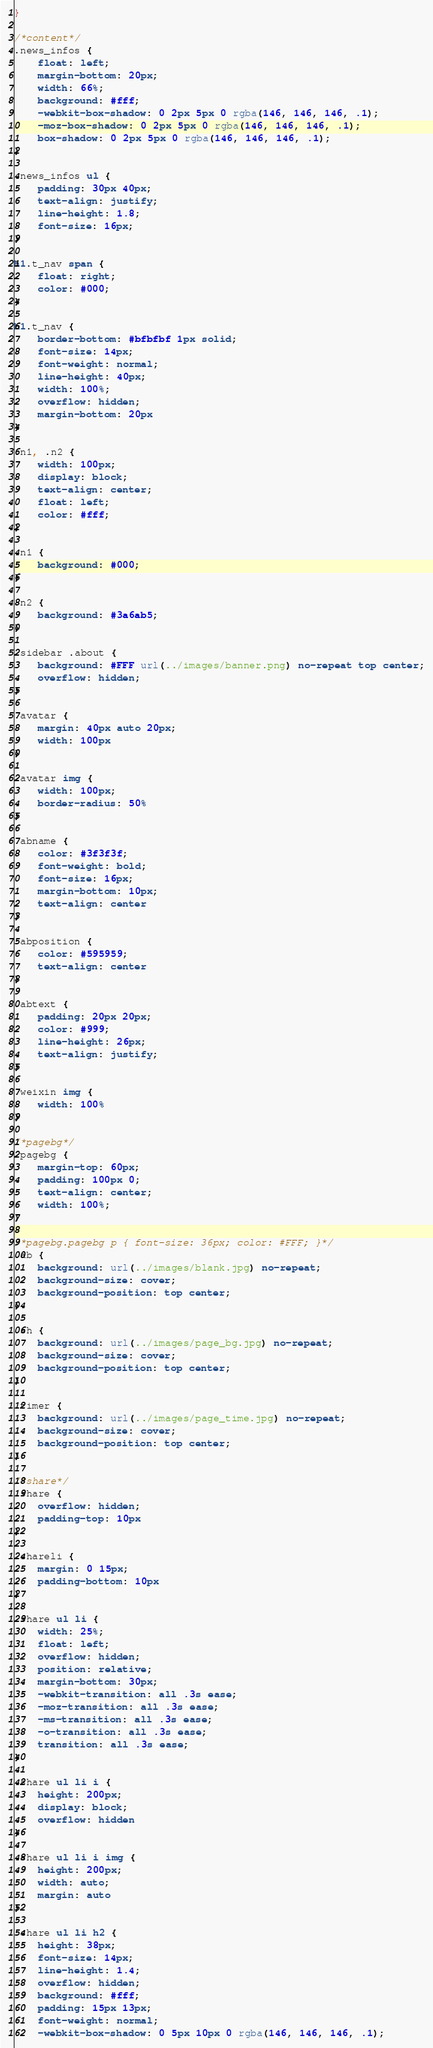<code> <loc_0><loc_0><loc_500><loc_500><_CSS_>}

/*content*/
.news_infos {
    float: left;
    margin-bottom: 20px;
    width: 66%;
    background: #fff;
    -webkit-box-shadow: 0 2px 5px 0 rgba(146, 146, 146, .1);
    -moz-box-shadow: 0 2px 5px 0 rgba(146, 146, 146, .1);
    box-shadow: 0 2px 5px 0 rgba(146, 146, 146, .1);
}

.news_infos ul {
    padding: 30px 40px;
    text-align: justify;
    line-height: 1.8;
    font-size: 16px;
}

h1.t_nav span {
    float: right;
    color: #000;
}

h1.t_nav {
    border-bottom: #bfbfbf 1px solid;
    font-size: 14px;
    font-weight: normal;
    line-height: 40px;
    width: 100%;
    overflow: hidden;
    margin-bottom: 20px
}

.n1, .n2 {
    width: 100px;
    display: block;
    text-align: center;
    float: left;
    color: #fff;
}

.n1 {
    background: #000;
}

.n2 {
    background: #3a6ab5;
}

.sidebar .about {
    background: #FFF url(../images/banner.png) no-repeat top center;
    overflow: hidden;
}

.avatar {
    margin: 40px auto 20px;
    width: 100px
}

.avatar img {
    width: 100px;
    border-radius: 50%
}

.abname {
    color: #3f3f3f;
    font-weight: bold;
    font-size: 16px;
    margin-bottom: 10px;
    text-align: center
}

.abposition {
    color: #595959;
    text-align: center
}

.abtext {
    padding: 20px 20px;
    color: #999;
    line-height: 26px;
    text-align: justify;
}

.weixin img {
    width: 100%
}

/*pagebg*/
.pagebg {
    margin-top: 60px;
    padding: 100px 0;
    text-align: center;
    width: 100%;
}

/*pagebg.pagebg p { font-size: 36px; color: #FFF; }*/
.ab {
    background: url(../images/blank.jpg) no-repeat;
    background-size: cover;
    background-position: top center;
}

.sh {
    background: url(../images/page_bg.jpg) no-repeat;
    background-size: cover;
    background-position: top center;
}

.timer {
    background: url(../images/page_time.jpg) no-repeat;
    background-size: cover;
    background-position: top center;
}

/*share*/
.share {
    overflow: hidden;
    padding-top: 10px
}

.shareli {
    margin: 0 15px;
    padding-bottom: 10px
}

.share ul li {
    width: 25%;
    float: left;
    overflow: hidden;
    position: relative;
    margin-bottom: 30px;
    -webkit-transition: all .3s ease;
    -moz-transition: all .3s ease;
    -ms-transition: all .3s ease;
    -o-transition: all .3s ease;
    transition: all .3s ease;
}

.share ul li i {
    height: 200px;
    display: block;
    overflow: hidden
}

.share ul li i img {
    height: 200px;
    width: auto;
    margin: auto
}

.share ul li h2 {
    height: 38px;
    font-size: 14px;
    line-height: 1.4;
    overflow: hidden;
    background: #fff;
    padding: 15px 13px;
    font-weight: normal;
    -webkit-box-shadow: 0 5px 10px 0 rgba(146, 146, 146, .1);</code> 